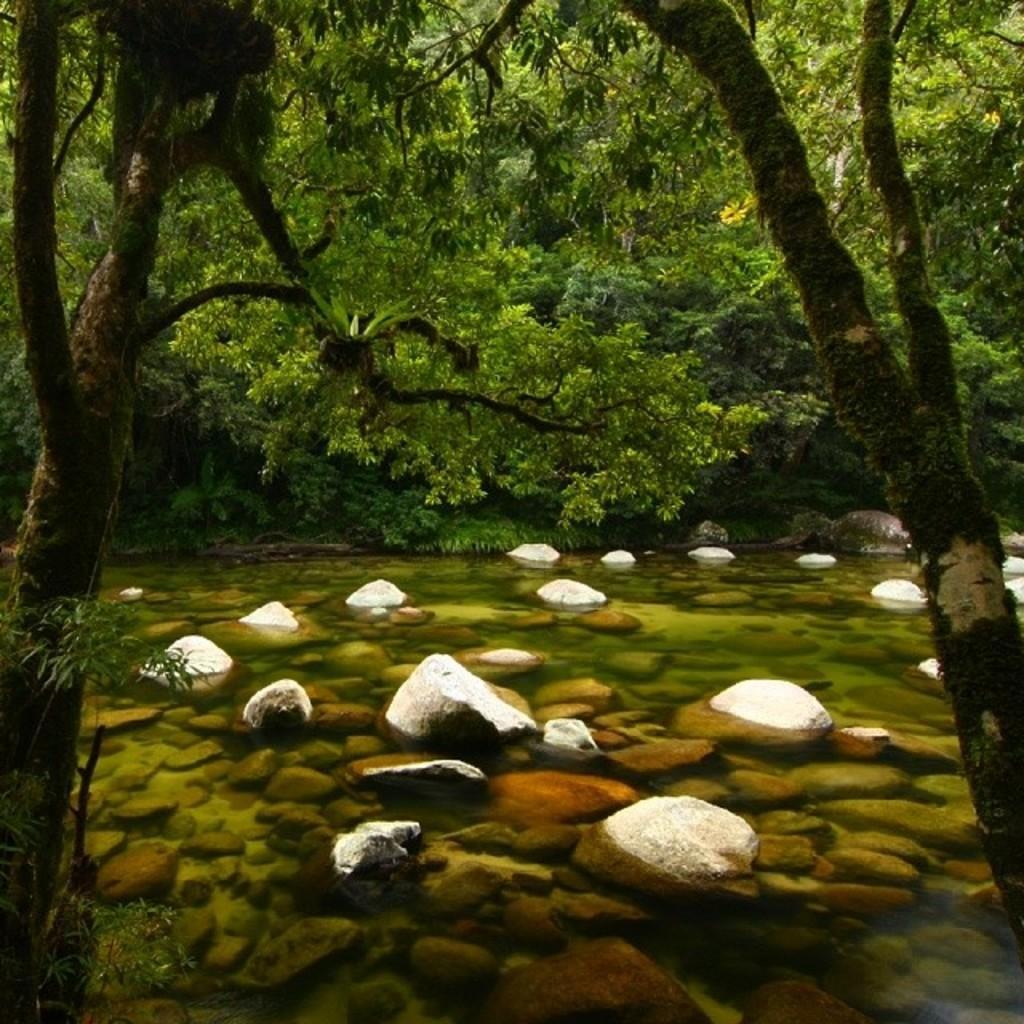Please provide a concise description of this image. As we can see in the image there are rocks, water and trees. 